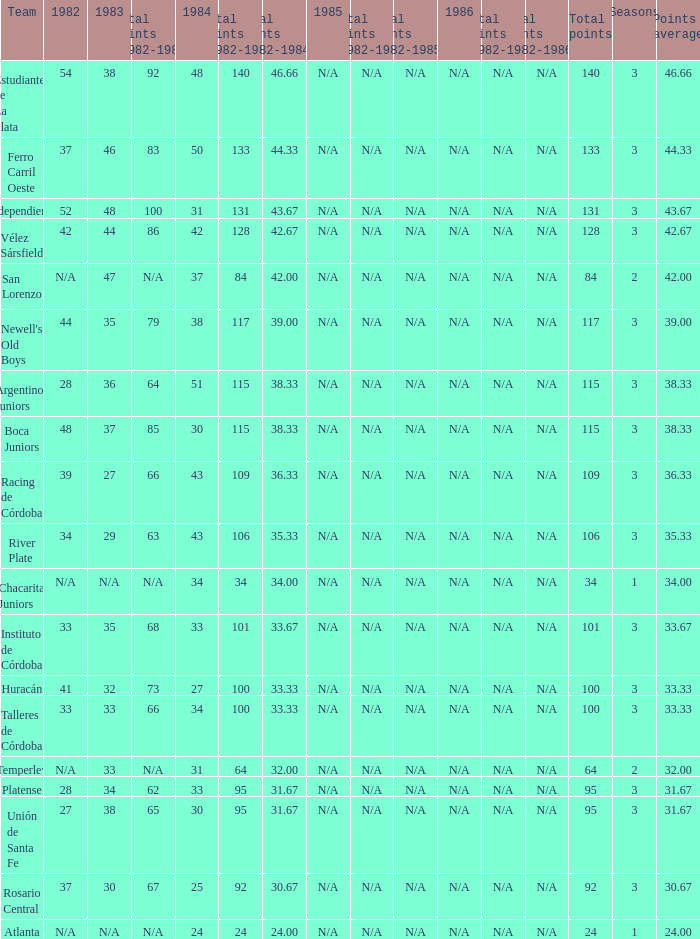What is the points total for the team with points average more than 34, 1984 score more than 37 and N/A in 1982? 0.0. 